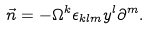Convert formula to latex. <formula><loc_0><loc_0><loc_500><loc_500>\vec { n } = - \Omega ^ { k } \epsilon _ { k l m } { y ^ { l } } \partial ^ { m } .</formula> 